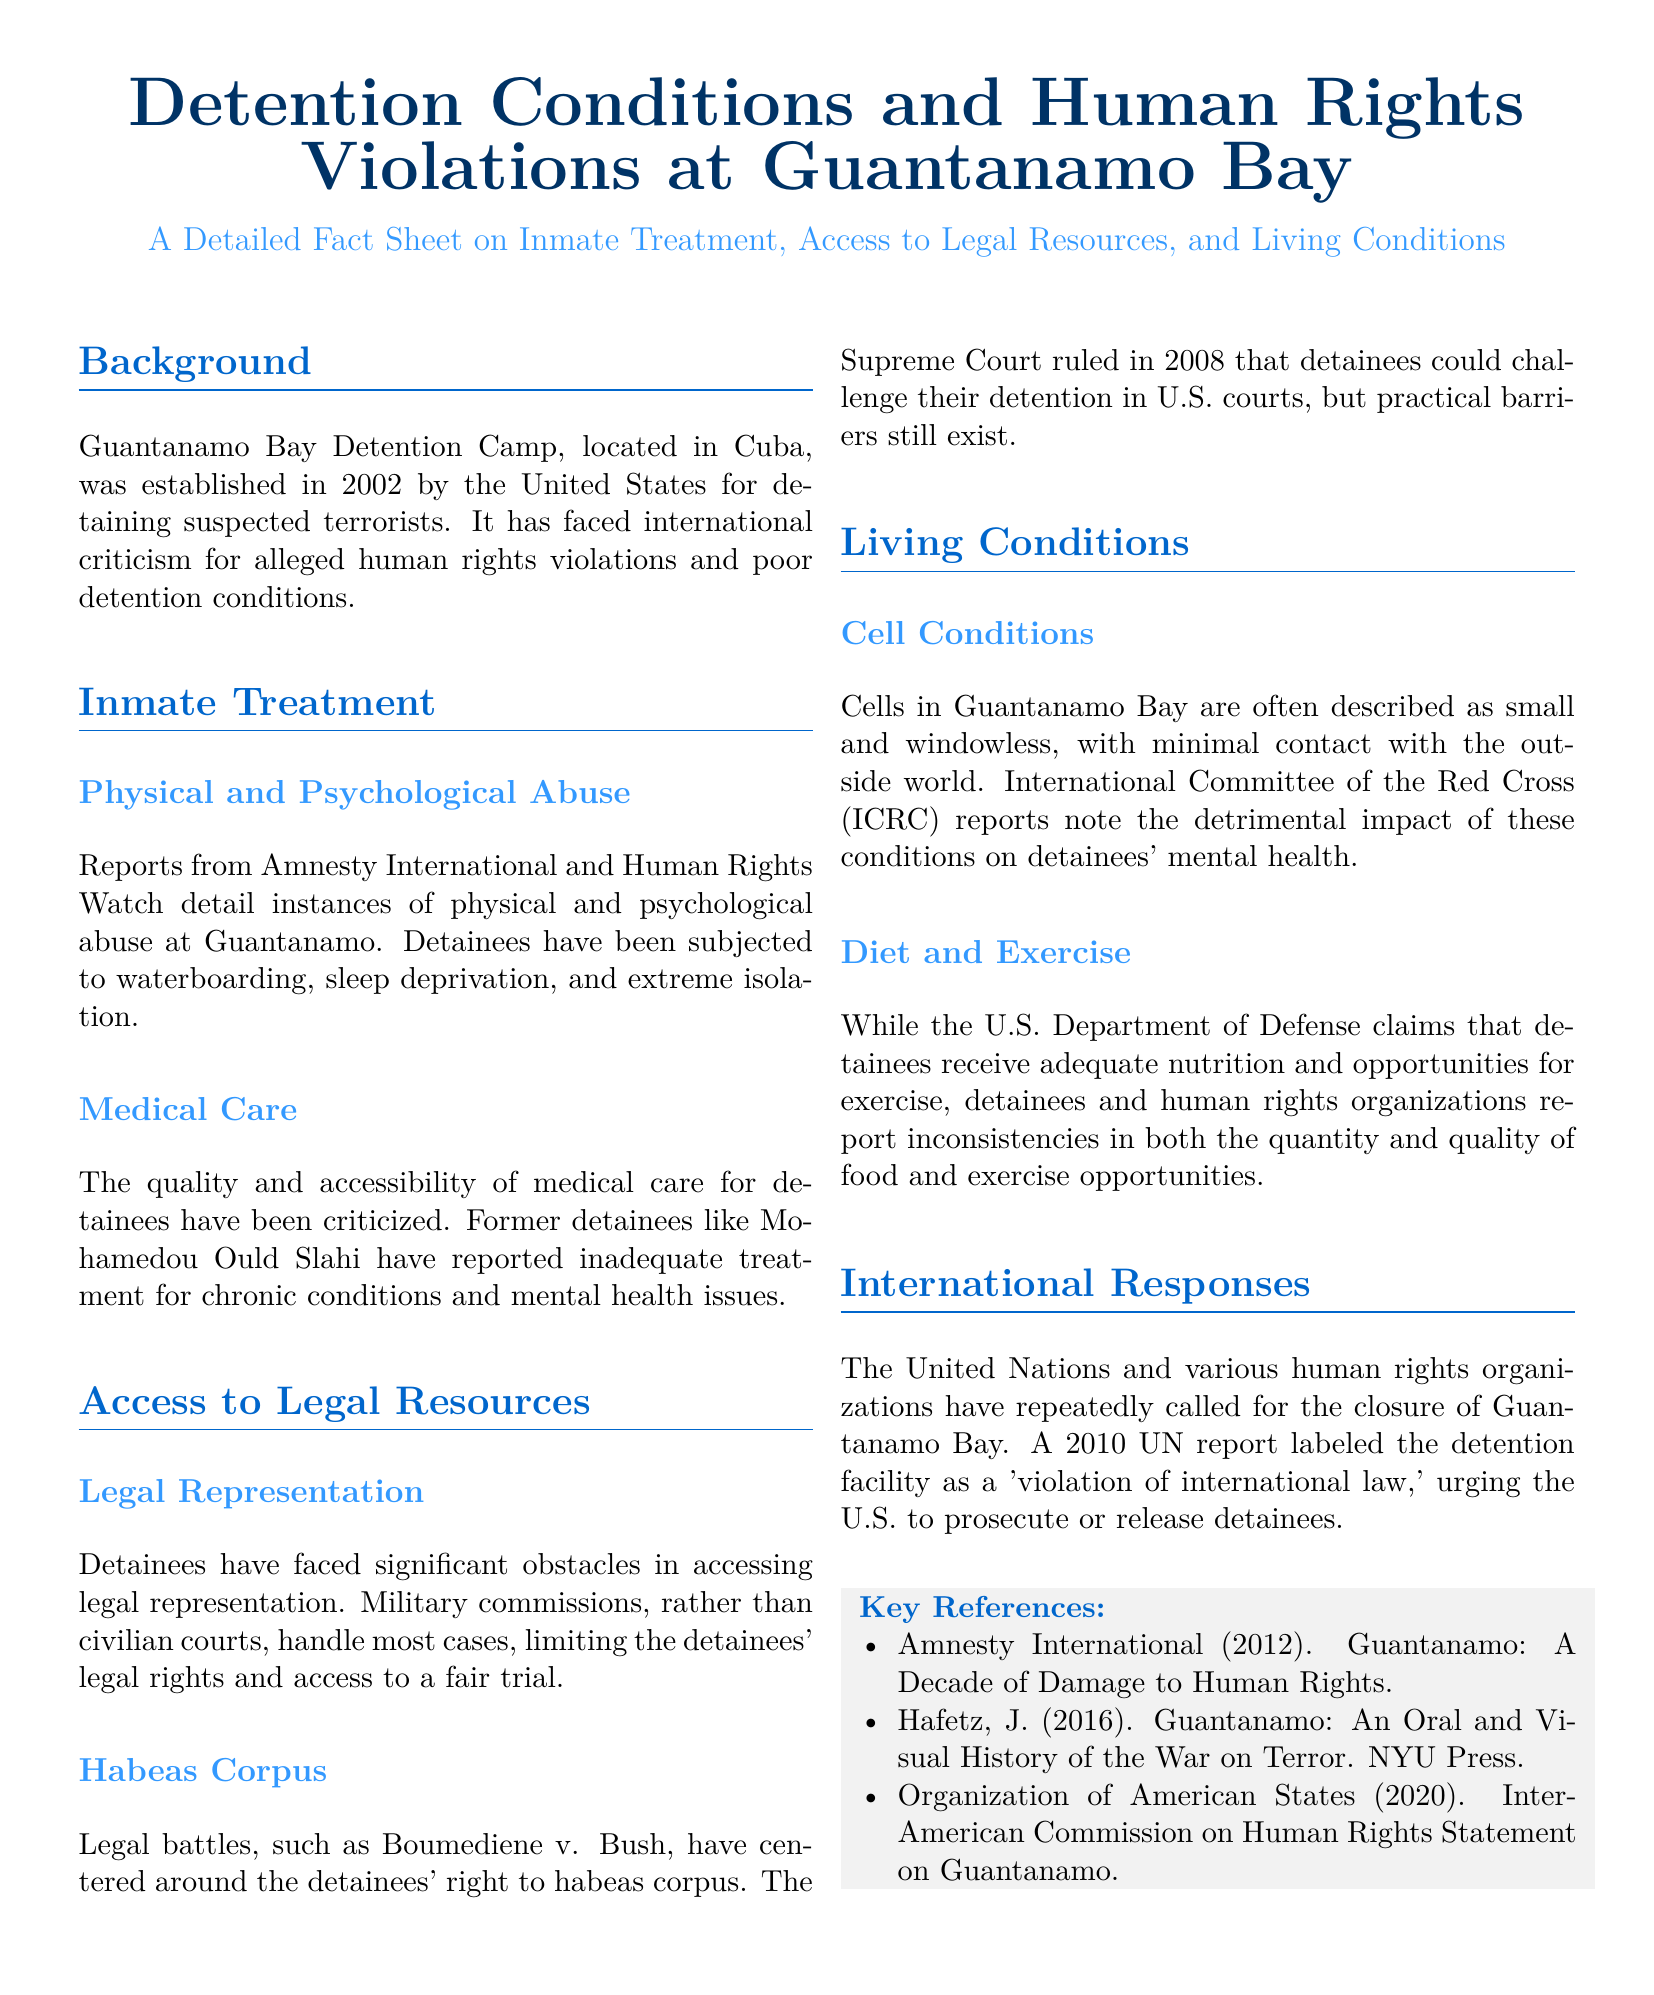what year was the Guantanamo Bay Detention Camp established? The document states that the detention camp was established in 2002.
Answer: 2002 what are some forms of abuse reported at Guantanamo? The document lists waterboarding, sleep deprivation, and extreme isolation as forms of abuse.
Answer: Waterboarding, sleep deprivation, extreme isolation what challenges do detainees face regarding legal representation? The document mentions that military commissions limit detainees' legal rights and access to a fair trial.
Answer: Military commissions what was the Supreme Court ruling in Boumediene v. Bush? The document notes that the Supreme Court ruled detainees could challenge their detention in U.S. courts.
Answer: Challenge detention in U.S. courts how did the UN describe Guantanamo in a 2010 report? The report labeled the facility as a 'violation of international law.'
Answer: Violation of international law what organization reported on the mental health effects of cell conditions? The document indicates that the International Committee of the Red Cross reported on the impact of cell conditions.
Answer: International Committee of the Red Cross how many references are listed in the Key References section? The Key References section contains three references.
Answer: Three what do former detainees report about medical care at Guantanamo? They reported inadequate treatment for chronic conditions and mental health issues.
Answer: Inadequate treatment for chronic conditions and mental health issues what is the main focus of this fact sheet? The fact sheet focuses on inmate treatment, access to legal resources, and living conditions.
Answer: Inmate treatment, access to legal resources, and living conditions 